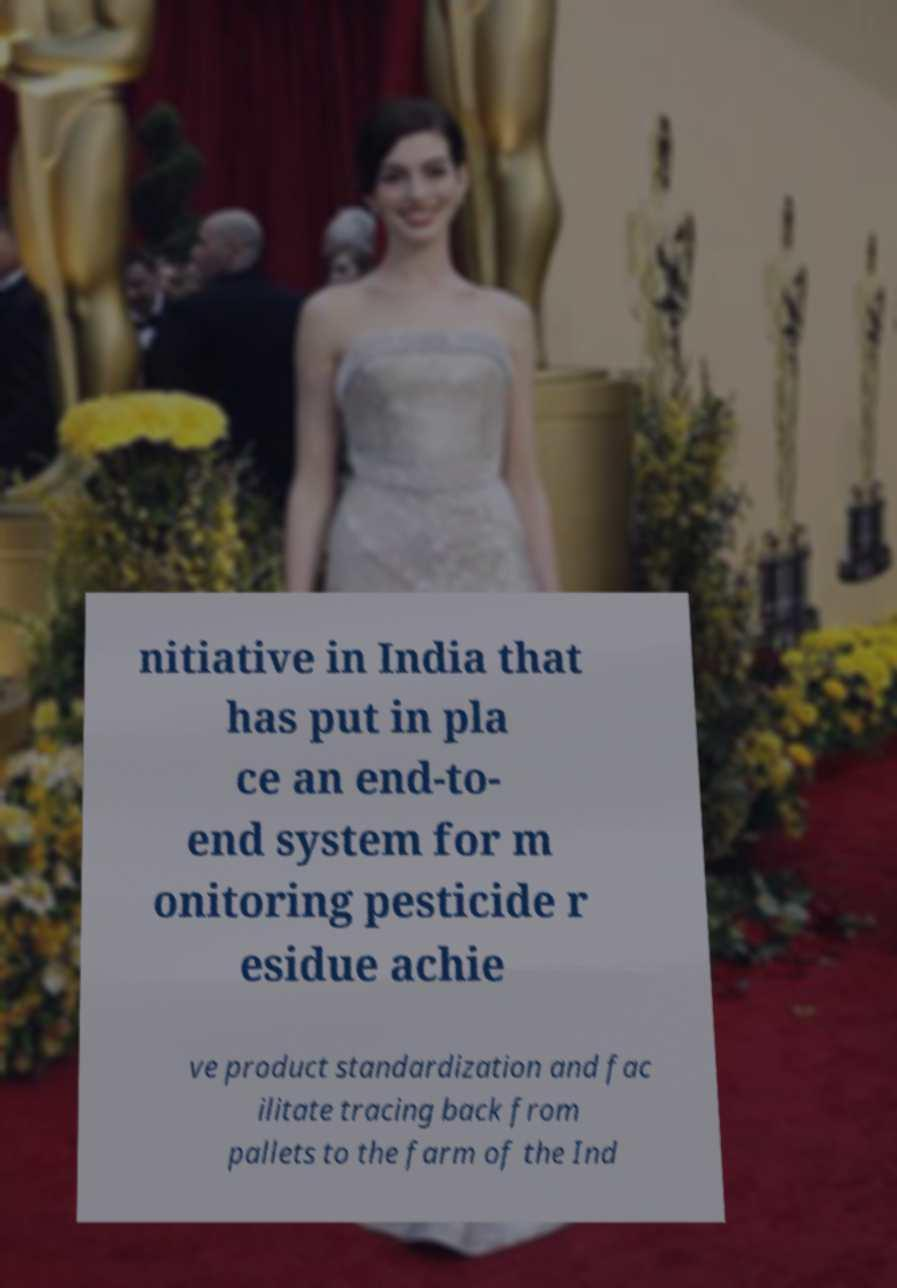For documentation purposes, I need the text within this image transcribed. Could you provide that? nitiative in India that has put in pla ce an end-to- end system for m onitoring pesticide r esidue achie ve product standardization and fac ilitate tracing back from pallets to the farm of the Ind 